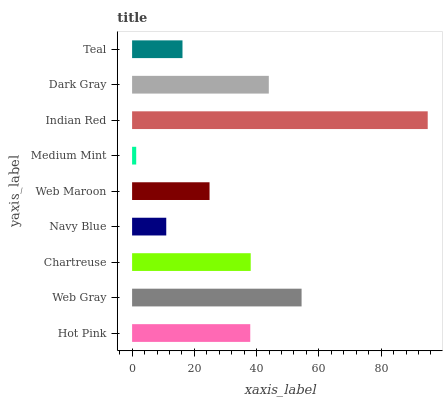Is Medium Mint the minimum?
Answer yes or no. Yes. Is Indian Red the maximum?
Answer yes or no. Yes. Is Web Gray the minimum?
Answer yes or no. No. Is Web Gray the maximum?
Answer yes or no. No. Is Web Gray greater than Hot Pink?
Answer yes or no. Yes. Is Hot Pink less than Web Gray?
Answer yes or no. Yes. Is Hot Pink greater than Web Gray?
Answer yes or no. No. Is Web Gray less than Hot Pink?
Answer yes or no. No. Is Hot Pink the high median?
Answer yes or no. Yes. Is Hot Pink the low median?
Answer yes or no. Yes. Is Web Gray the high median?
Answer yes or no. No. Is Web Maroon the low median?
Answer yes or no. No. 